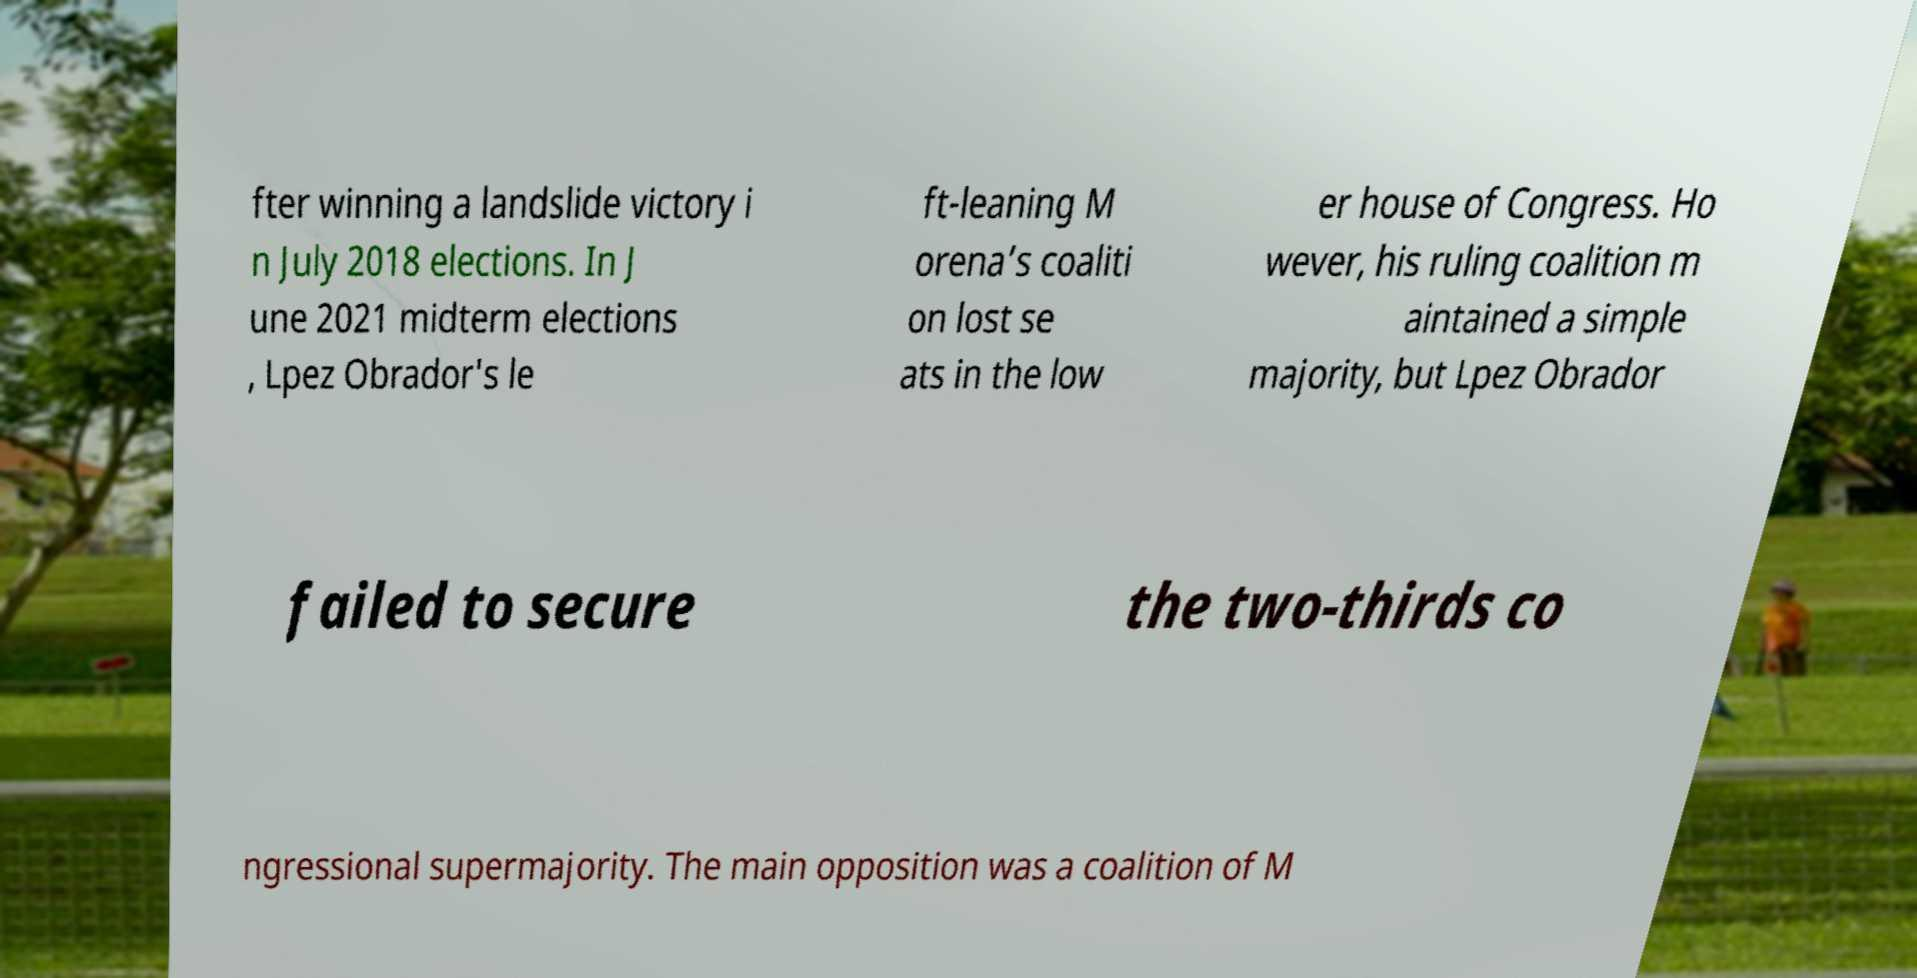Could you assist in decoding the text presented in this image and type it out clearly? fter winning a landslide victory i n July 2018 elections. In J une 2021 midterm elections , Lpez Obrador's le ft-leaning M orena’s coaliti on lost se ats in the low er house of Congress. Ho wever, his ruling coalition m aintained a simple majority, but Lpez Obrador failed to secure the two-thirds co ngressional supermajority. The main opposition was a coalition of M 